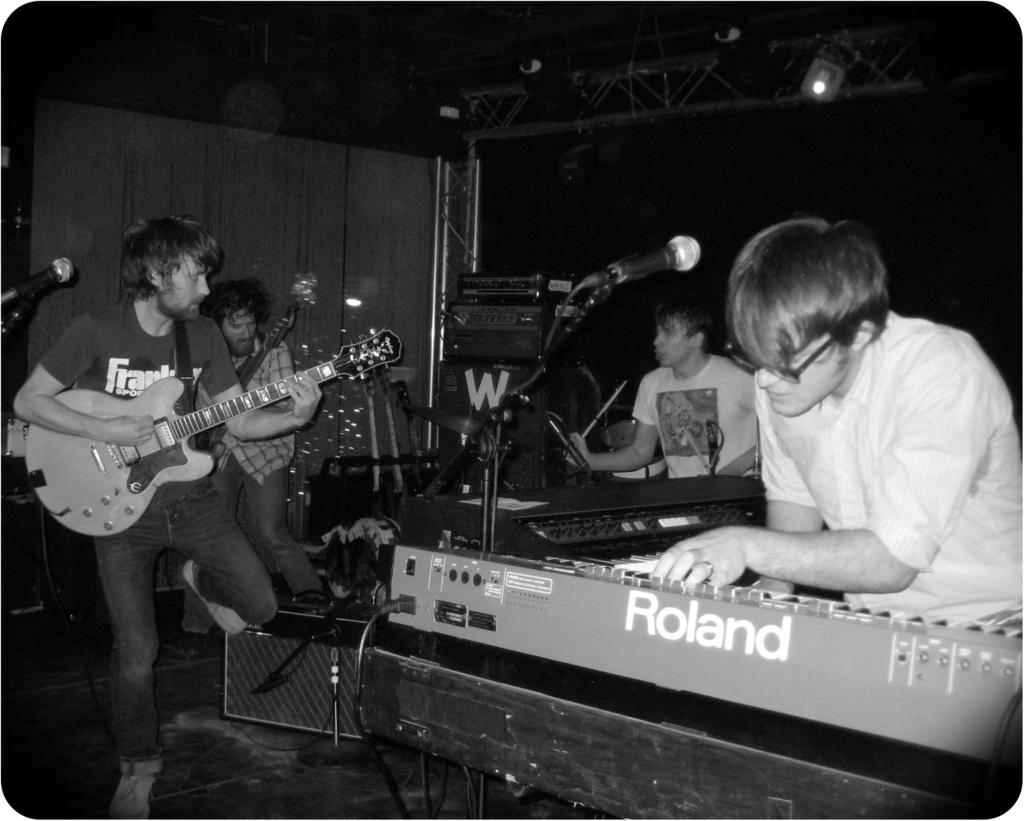<image>
Give a short and clear explanation of the subsequent image. Four men play their instruments, one in front of a keyboard that says Roland 